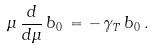<formula> <loc_0><loc_0><loc_500><loc_500>\, \mu \, \frac { d } { d \mu } \, b _ { 0 } \, = - \, \gamma _ { T } \, b _ { 0 } \, .</formula> 